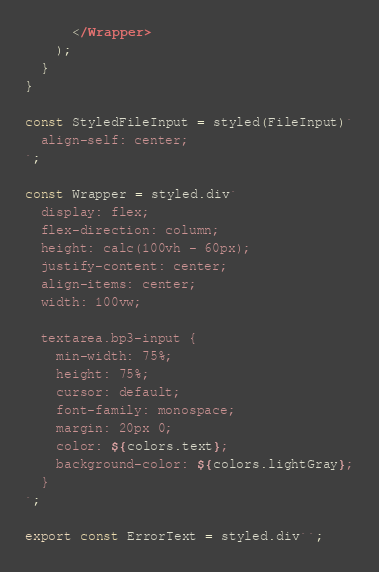<code> <loc_0><loc_0><loc_500><loc_500><_TypeScript_>      </Wrapper>
    );
  }
}

const StyledFileInput = styled(FileInput)`
  align-self: center;
`;

const Wrapper = styled.div`
  display: flex;
  flex-direction: column;
  height: calc(100vh - 60px);
  justify-content: center;
  align-items: center;
  width: 100vw;

  textarea.bp3-input {
    min-width: 75%;
    height: 75%;
    cursor: default;
    font-family: monospace;
    margin: 20px 0;
    color: ${colors.text};
    background-color: ${colors.lightGray};
  }
`;

export const ErrorText = styled.div``;
</code> 